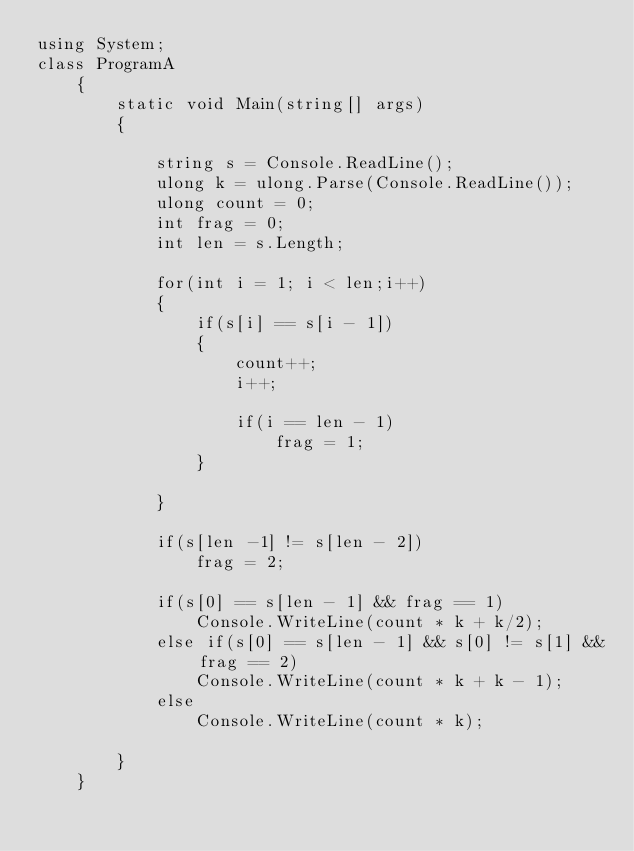<code> <loc_0><loc_0><loc_500><loc_500><_C#_>using System;
class ProgramA
    {
        static void Main(string[] args)
        {
            
            string s = Console.ReadLine();
            ulong k = ulong.Parse(Console.ReadLine());
            ulong count = 0;
            int frag = 0;
            int len = s.Length;

            for(int i = 1; i < len;i++)
            {
                if(s[i] == s[i - 1])
                {
                    count++;
                    i++;
                    
                    if(i == len - 1)
                        frag = 1;
                }
            
            }

            if(s[len -1] != s[len - 2])
                frag = 2;

            if(s[0] == s[len - 1] && frag == 1)
                Console.WriteLine(count * k + k/2);
            else if(s[0] == s[len - 1] && s[0] != s[1] && frag == 2)
                Console.WriteLine(count * k + k - 1);
            else
                Console.WriteLine(count * k);
     
        }
    }</code> 